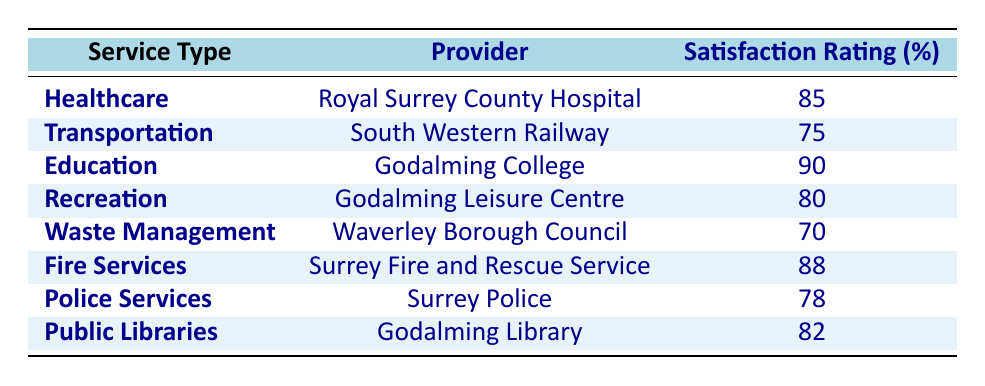What is the satisfaction rating for Healthcare services in Godalming? The table shows that the satisfaction rating for Healthcare services, specifically provided by Royal Surrey County Hospital, is 85%.
Answer: 85% Which service provider has the highest satisfaction rating in Godalming? By inspecting the satisfaction ratings in the table, Godalming College has the highest rating at 90%.
Answer: Godalming College Is the satisfaction rating for Waste Management higher than 75%? The table indicates that the satisfaction rating for Waste Management, provided by Waverley Borough Council, is 70%, which is lower than 75%.
Answer: No What is the average satisfaction rating of the Recreation and Police Services? The satisfaction rating for Recreation services is 80% and for Police Services it is 78%. To find the average, we sum these (80 + 78 = 158) and then divide by 2, giving us an average rating of 79%.
Answer: 79% Does the Royal Surrey County Hospital provide services with a satisfaction rating lower than 90%? The satisfaction rating for Healthcare services at Royal Surrey County Hospital is 85%, which is lower than 90%.
Answer: Yes Which two service types have satisfaction ratings in the 70s? The table lists Waste Management with a satisfaction rating of 70% and Transportation with a rating of 75%. Therefore, the two service types are Waste Management and Transportation.
Answer: Waste Management and Transportation What is the difference in satisfaction ratings between Fire Services and Healthcare? Fire Services has a satisfaction rating of 88% while Healthcare has 85%. The difference is 88 - 85 = 3%, indicating that Fire Services are rated 3% higher than Healthcare.
Answer: 3% Are Public Libraries rated better than Police Services based on satisfaction? Public Libraries have a satisfaction rating of 82%, while Police Services have 78%. Since 82% is greater than 78%, Public Libraries are indeed rated better than Police Services.
Answer: Yes What is the total satisfaction rating for all services listed in Godalming? To get the total, we add the satisfaction ratings from each service: 85 + 75 + 90 + 80 + 70 + 88 + 78 + 82 = 638. The total satisfaction rating for all services is 638%.
Answer: 638% 